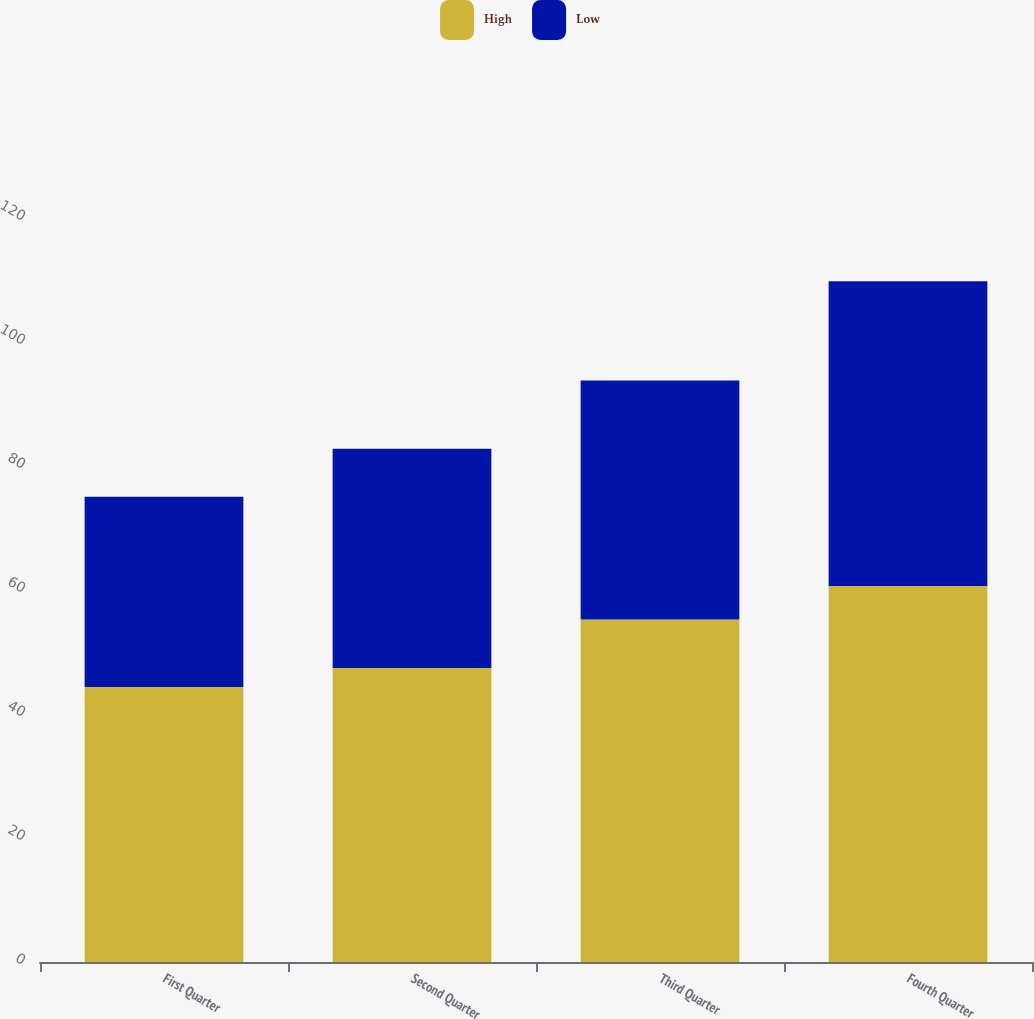Convert chart. <chart><loc_0><loc_0><loc_500><loc_500><stacked_bar_chart><ecel><fcel>First Quarter<fcel>Second Quarter<fcel>Third Quarter<fcel>Fourth Quarter<nl><fcel>High<fcel>44.36<fcel>47.41<fcel>55.25<fcel>60.64<nl><fcel>Low<fcel>30.67<fcel>35.36<fcel>38.55<fcel>49.14<nl></chart> 